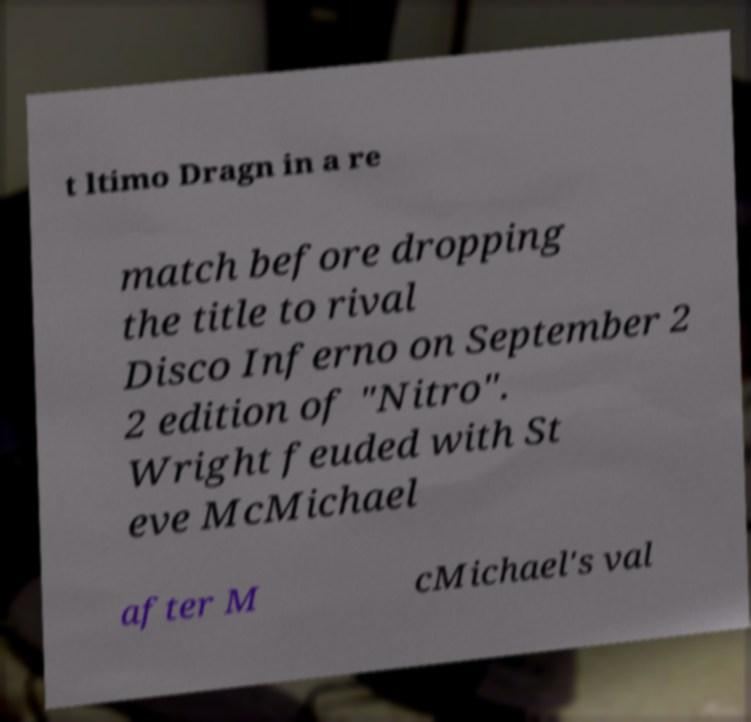Please read and relay the text visible in this image. What does it say? t ltimo Dragn in a re match before dropping the title to rival Disco Inferno on September 2 2 edition of "Nitro". Wright feuded with St eve McMichael after M cMichael's val 